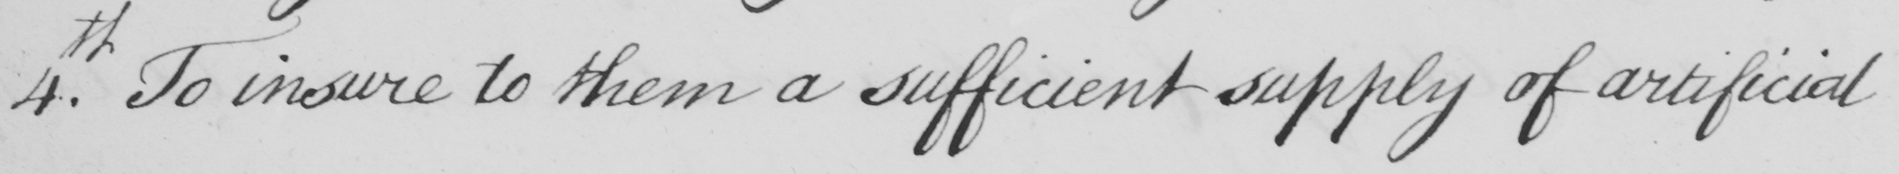What text is written in this handwritten line? 4th. To insure to them a sufficient supply of artificial 